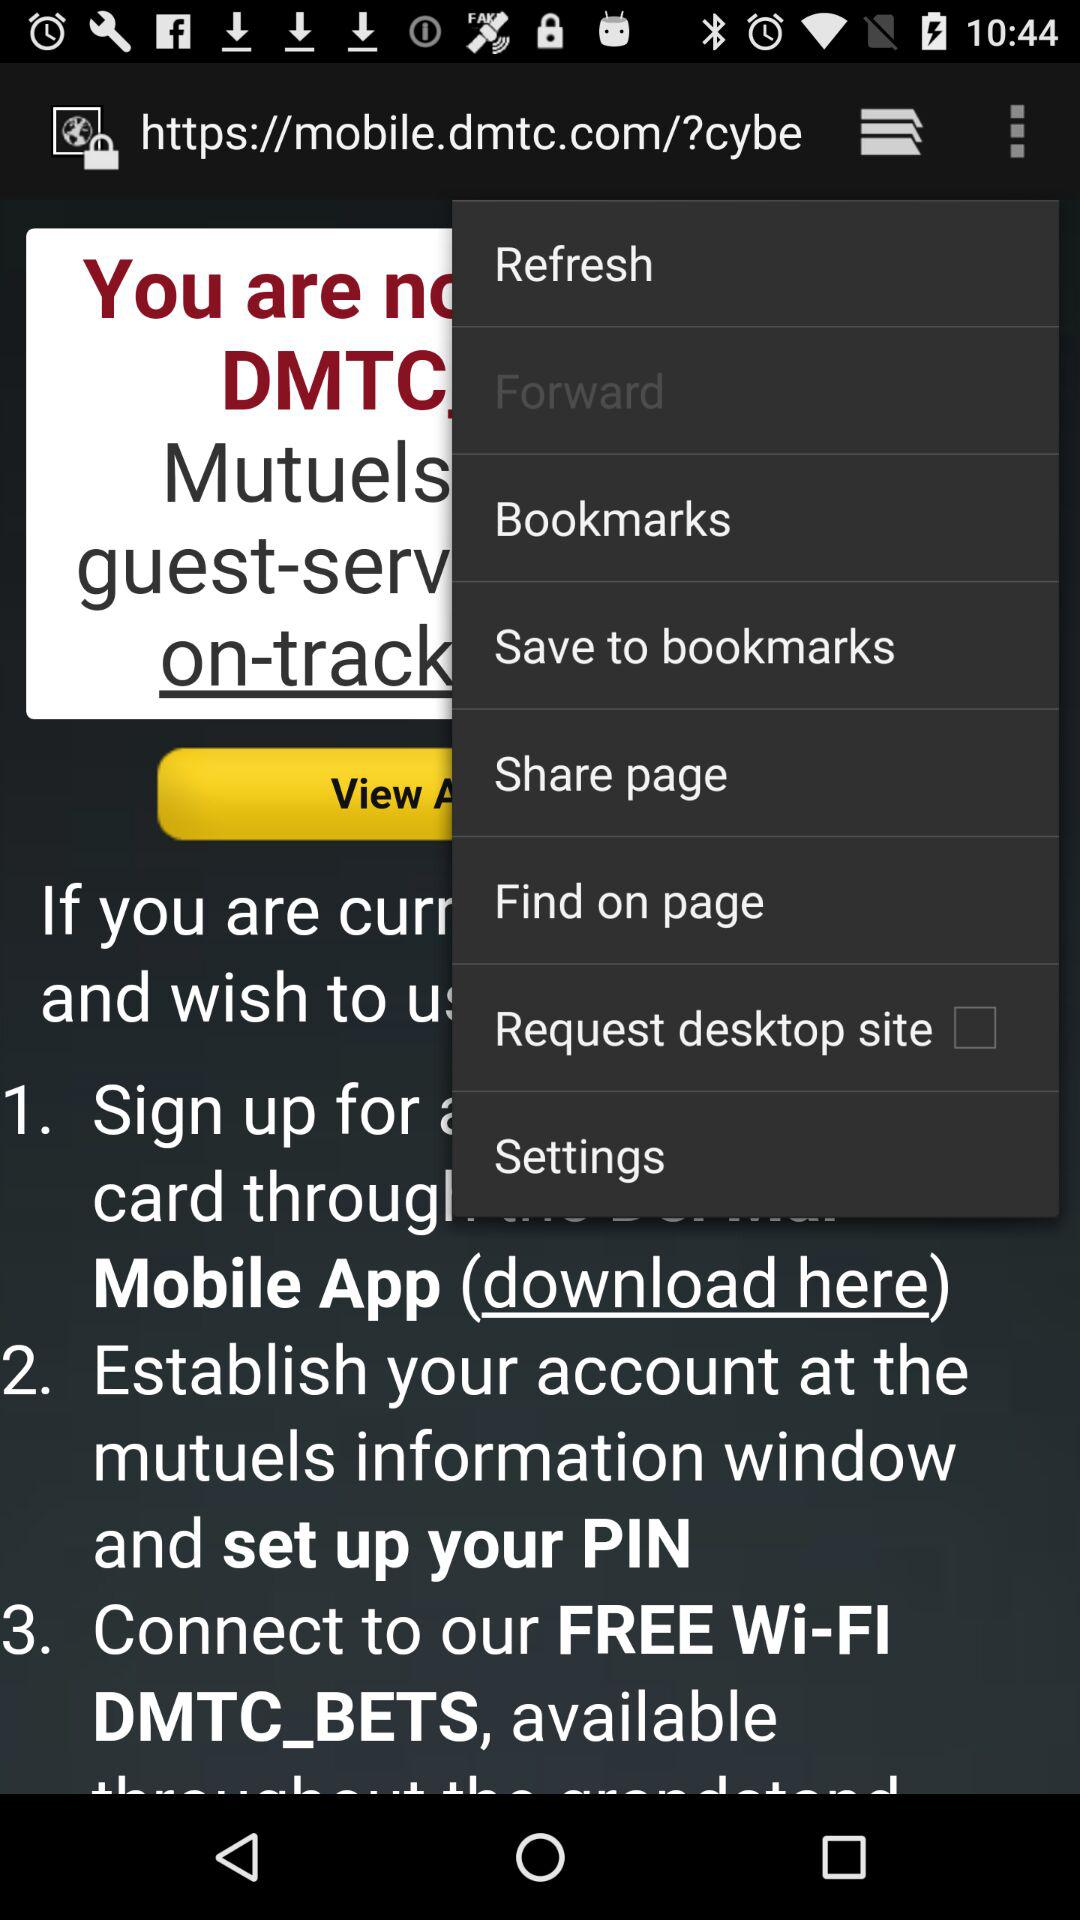How many ways can I sign up for a card?
Answer the question using a single word or phrase. 3 